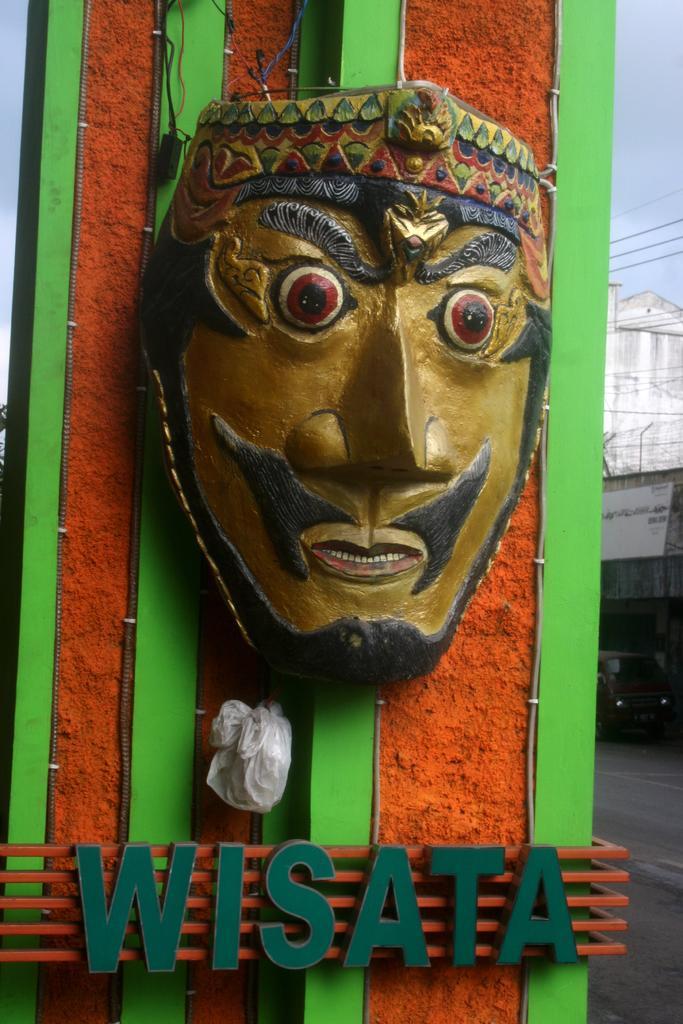Could you give a brief overview of what you see in this image? In this image we can see a mask, text, cables and objects on the wall. In the background we can see clouds in the sky, electric wires, building and other objects. 